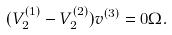Convert formula to latex. <formula><loc_0><loc_0><loc_500><loc_500>( V _ { 2 } ^ { ( 1 ) } - V _ { 2 } ^ { ( 2 ) } ) v ^ { ( 3 ) } = 0 \Omega .</formula> 